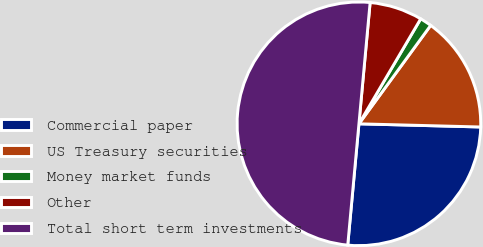Convert chart. <chart><loc_0><loc_0><loc_500><loc_500><pie_chart><fcel>Commercial paper<fcel>US Treasury securities<fcel>Money market funds<fcel>Other<fcel>Total short term investments<nl><fcel>26.05%<fcel>15.39%<fcel>1.56%<fcel>7.0%<fcel>50.0%<nl></chart> 